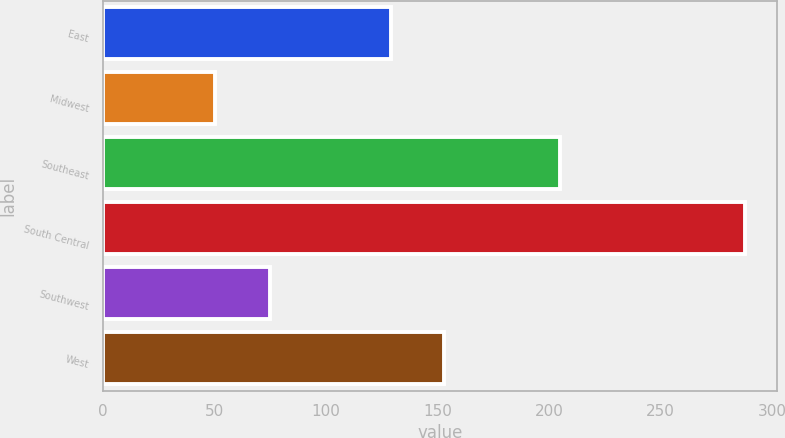<chart> <loc_0><loc_0><loc_500><loc_500><bar_chart><fcel>East<fcel>Midwest<fcel>Southeast<fcel>South Central<fcel>Southwest<fcel>West<nl><fcel>129<fcel>50<fcel>205<fcel>288<fcel>75<fcel>152.8<nl></chart> 